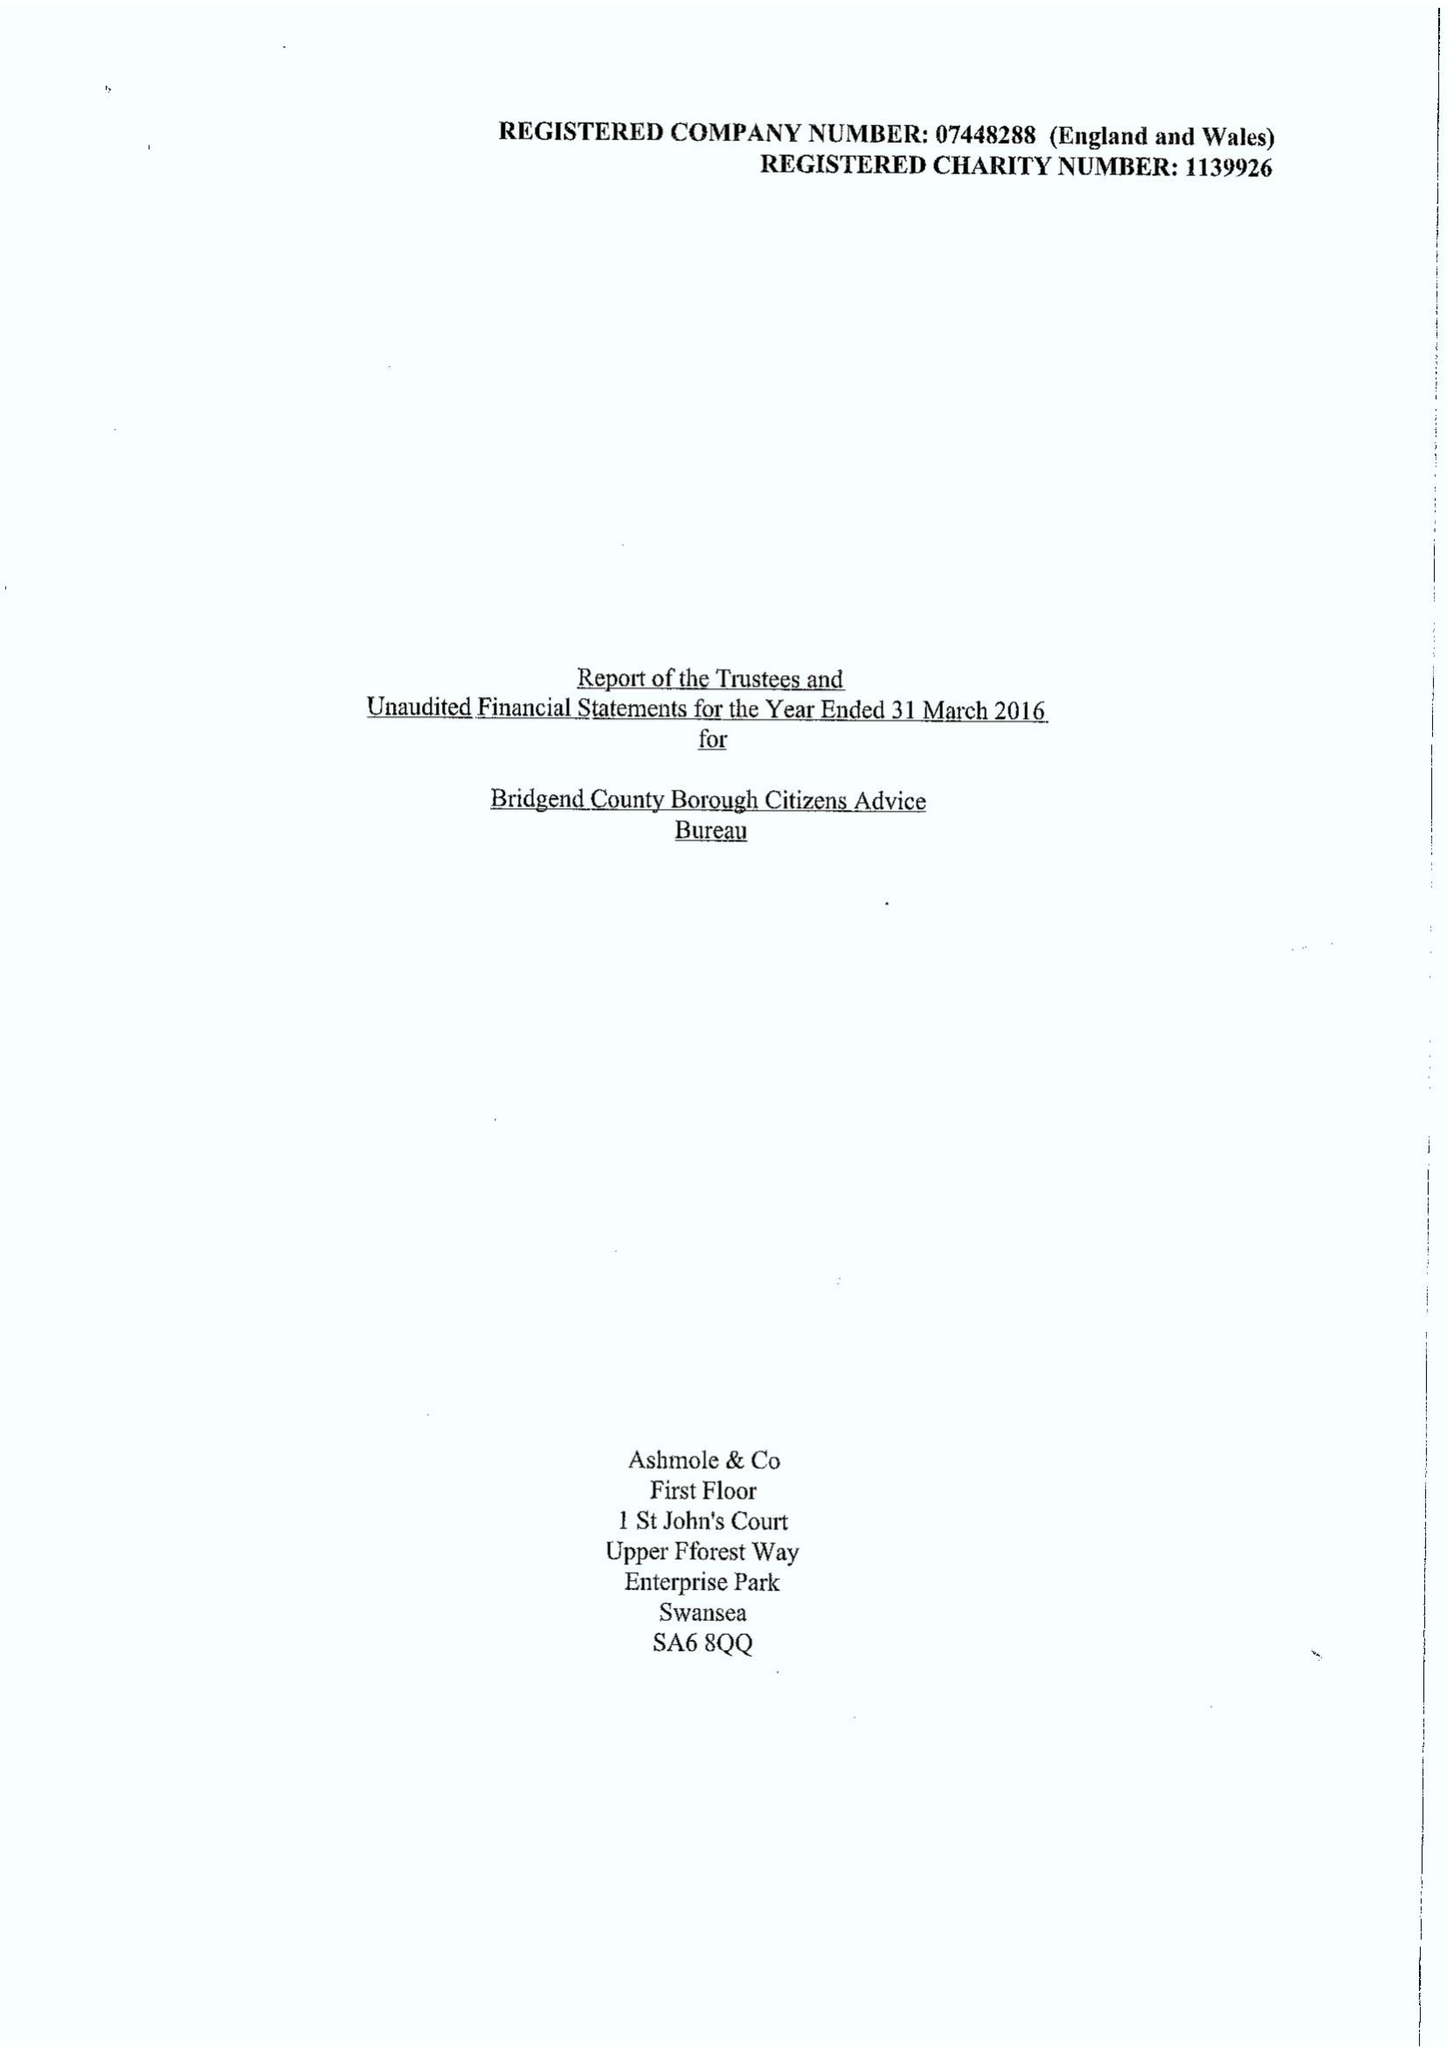What is the value for the report_date?
Answer the question using a single word or phrase. 2016-03-31 